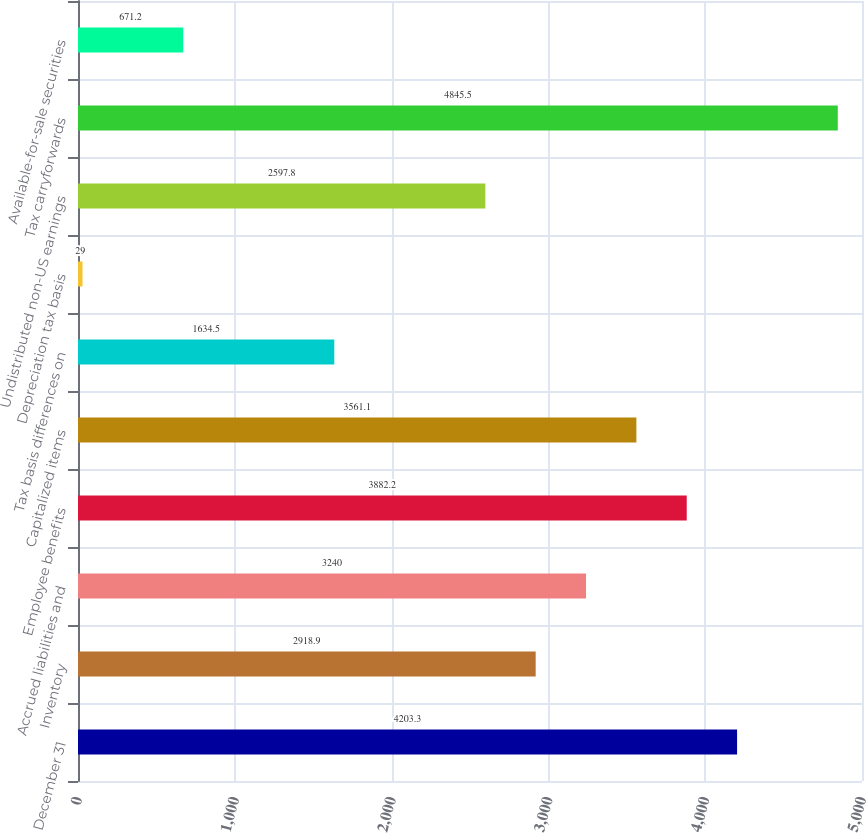Convert chart to OTSL. <chart><loc_0><loc_0><loc_500><loc_500><bar_chart><fcel>December 31<fcel>Inventory<fcel>Accrued liabilities and<fcel>Employee benefits<fcel>Capitalized items<fcel>Tax basis differences on<fcel>Depreciation tax basis<fcel>Undistributed non-US earnings<fcel>Tax carryforwards<fcel>Available-for-sale securities<nl><fcel>4203.3<fcel>2918.9<fcel>3240<fcel>3882.2<fcel>3561.1<fcel>1634.5<fcel>29<fcel>2597.8<fcel>4845.5<fcel>671.2<nl></chart> 